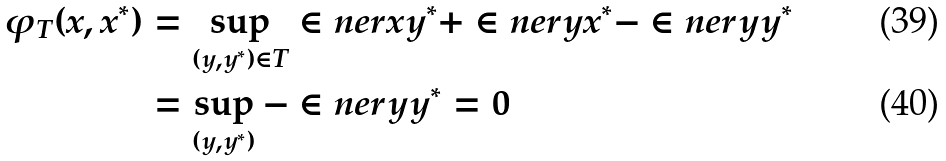Convert formula to latex. <formula><loc_0><loc_0><loc_500><loc_500>\varphi _ { T } ( x , x ^ { * } ) & = \sup _ { ( y , y ^ { * } ) \in T } \in n e r { x } { y ^ { * } } + \in n e r { y } { x ^ { * } } - \in n e r { y } { y ^ { * } } \\ & = \sup _ { ( y , y ^ { * } ) } - \in n e r { y } { y ^ { * } } = 0</formula> 